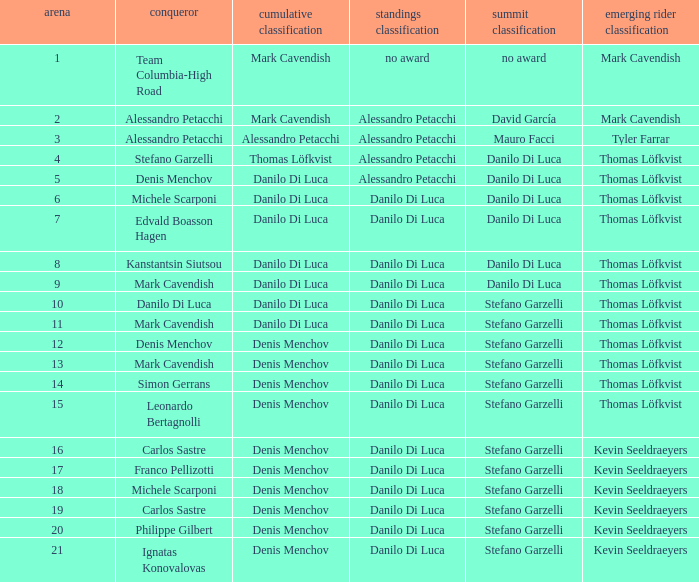When danilo di luca is the winner who is the general classification?  Danilo Di Luca. 